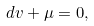<formula> <loc_0><loc_0><loc_500><loc_500>d v + \mu = 0 ,</formula> 